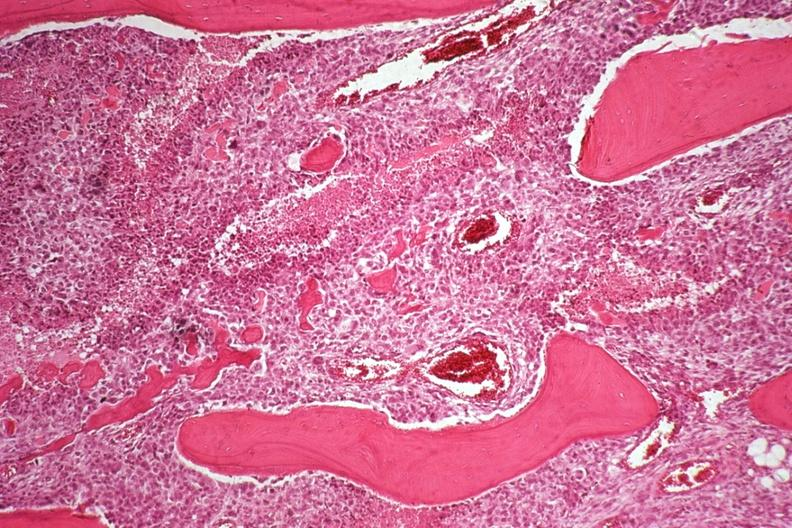what is present?
Answer the question using a single word or phrase. Joints 